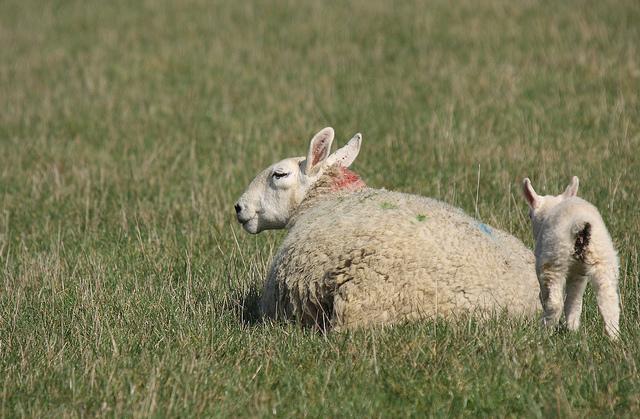How many total ears are there in this picture?
Short answer required. 4. What is the likely relationship between the animals?
Answer briefly. Parent and child. What is the animal wearing around it's neck?
Quick response, please. Nothing. Are these rabbits?
Short answer required. No. 